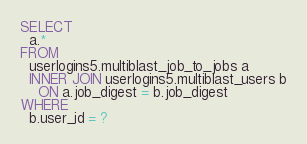<code> <loc_0><loc_0><loc_500><loc_500><_SQL_>SELECT
  a.*
FROM
  userlogins5.multiblast_job_to_jobs a
  INNER JOIN userlogins5.multiblast_users b
    ON a.job_digest = b.job_digest
WHERE
  b.user_id = ?
</code> 